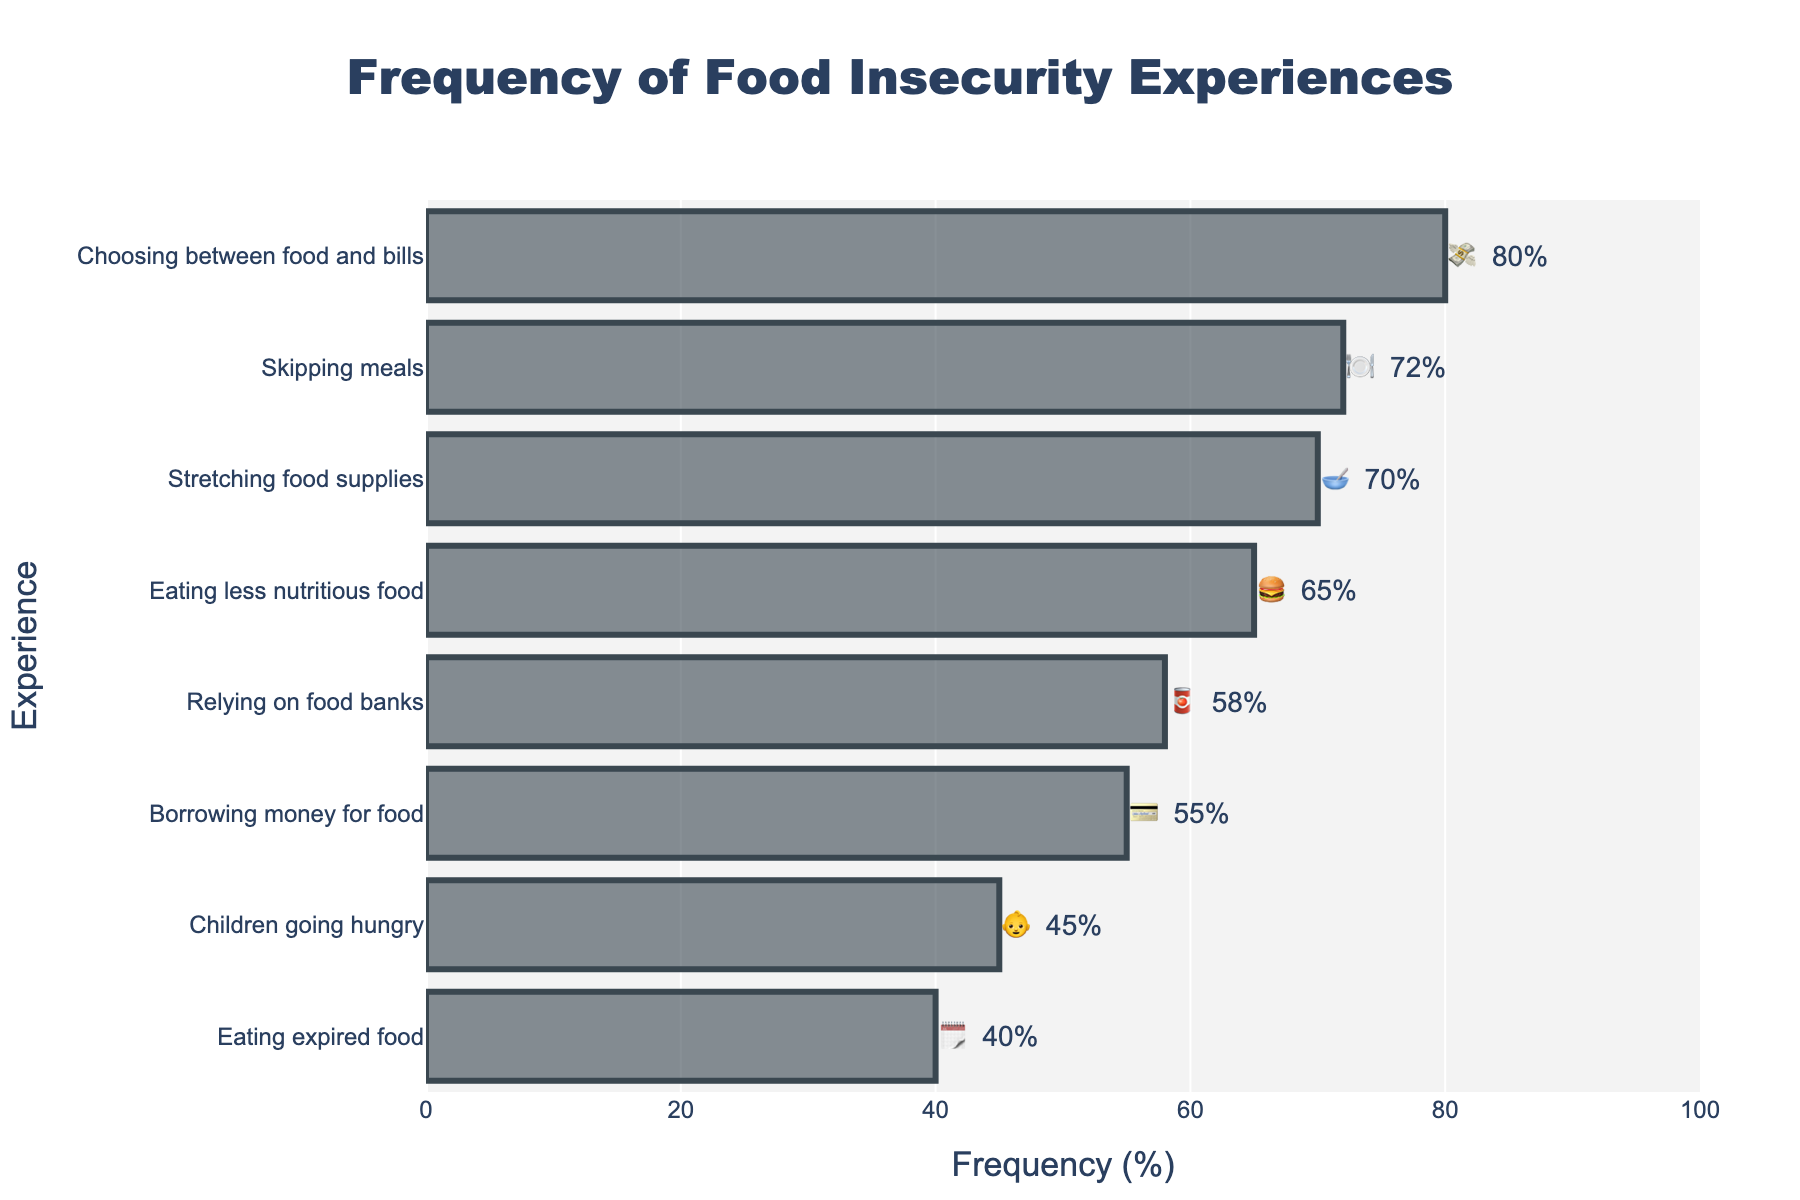Which food insecurity experience has the highest frequency? We look at the horizontal bars and find the one with the greatest length, which corresponds to "Choosing between food and bills" at 80%.
Answer: Choosing between food and bills Which experience has a 40% frequency? We identify the experience connected to the 40% mark on the frequency axis, which is "Eating expired food" with the emoji 🗓️.
Answer: Eating expired food How many experiences have frequencies greater than 50%? Counting the segments with length greater than the 50% mark gives us five experiences: Skipping meals (72%), Relying on food banks (58%), Eating less nutritious food (65%), Choosing between food and bills (80%), and Stretching food supplies (70%).
Answer: Five What is the combined frequency of "Skipping meals" and "Stretching food supplies"? Adding together the frequencies: 72% (🍽️) + 70% (🥣) = 142%.
Answer: 142% Which experience has the lowest frequency? Analyzing the graph shows the shortest bar corresponds to "Eating expired food" with a frequency of 40%.
Answer: Eating expired food Are there more experiences with frequencies above or below 50%? There are five experiences above 50% (Skipping meals, Relying on food banks, Eating less nutritious food, Choosing between food and bills, Stretching food supplies) and three below 50% (Children going hungry, Eating expired food, Borrowing money for food). Since 5 > 3, there are more experiences above 50%.
Answer: Above 50% What is the average frequency of "Eating less nutritious food" and "Children going hungry"? Calculating the average: (65% + 45%) / 2 = 55%.
Answer: 55% Which experience is indicated by the 🥣 emoji and what is its frequency? Referring to the emoji 🥣, we find it represents "Stretching food supplies" with a 70% frequency.
Answer: Stretching food supplies, 70% Which experience has a higher frequency, "Relying on food banks" or "Borrowing money for food"? Comparing the two, Relying on food banks has a frequency of 58% while Borrowing money for food has 55%. Therefore, Relying on food banks is higher.
Answer: Relying on food banks What is the difference in frequency between "Skipping meals" and "Eating expired food"? Subtracting the smaller frequency from the larger: 72% (Skipping meals) - 40% (Eating expired food) = 32%.
Answer: 32% 